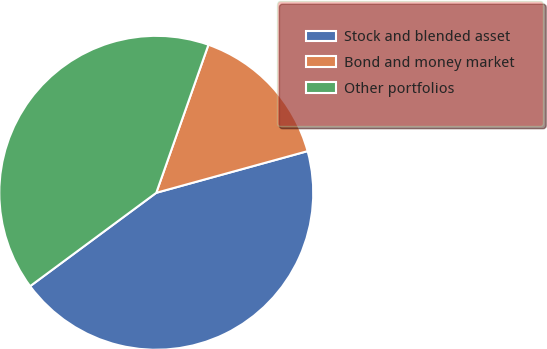<chart> <loc_0><loc_0><loc_500><loc_500><pie_chart><fcel>Stock and blended asset<fcel>Bond and money market<fcel>Other portfolios<nl><fcel>44.13%<fcel>15.33%<fcel>40.53%<nl></chart> 